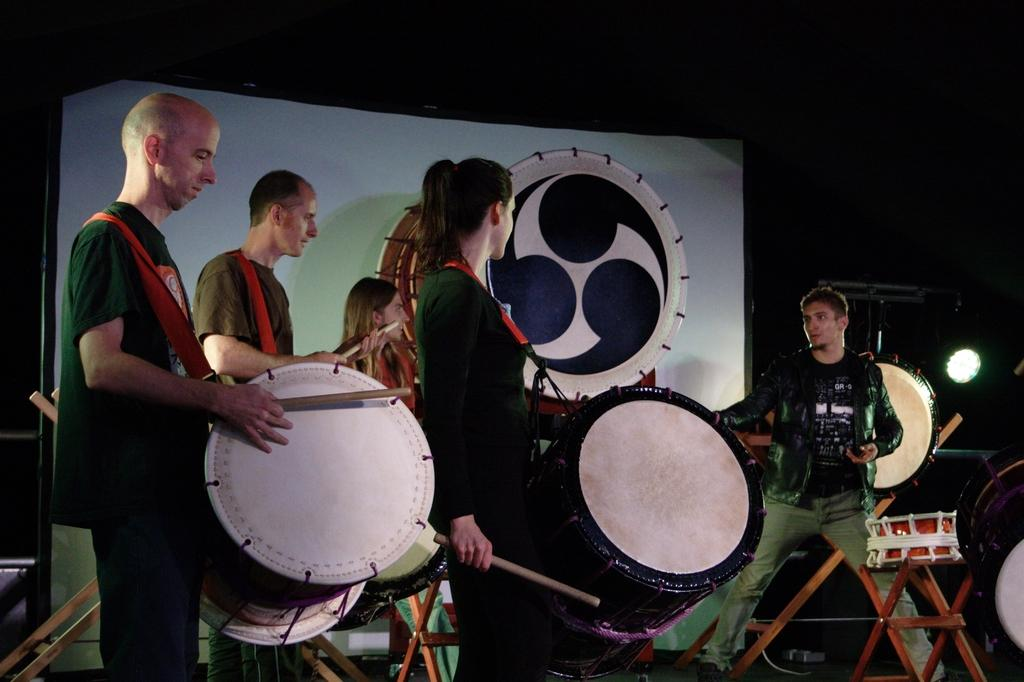What is happening in the image involving a group of people? The people in the image are playing drums. How are the people positioned in the image? The people are standing. Is there a specific person in the group with a distinct position? Yes, there is a person standing in front of the group. What else can be seen in the image besides the people and drums? There are lights visible in the image. How many drums are present in the image? There are drums in the image, but the exact number is not specified. What route are the people taking while playing drums in the image? There is no indication of a route or movement in the image; the people are standing and playing drums in a stationary position. 